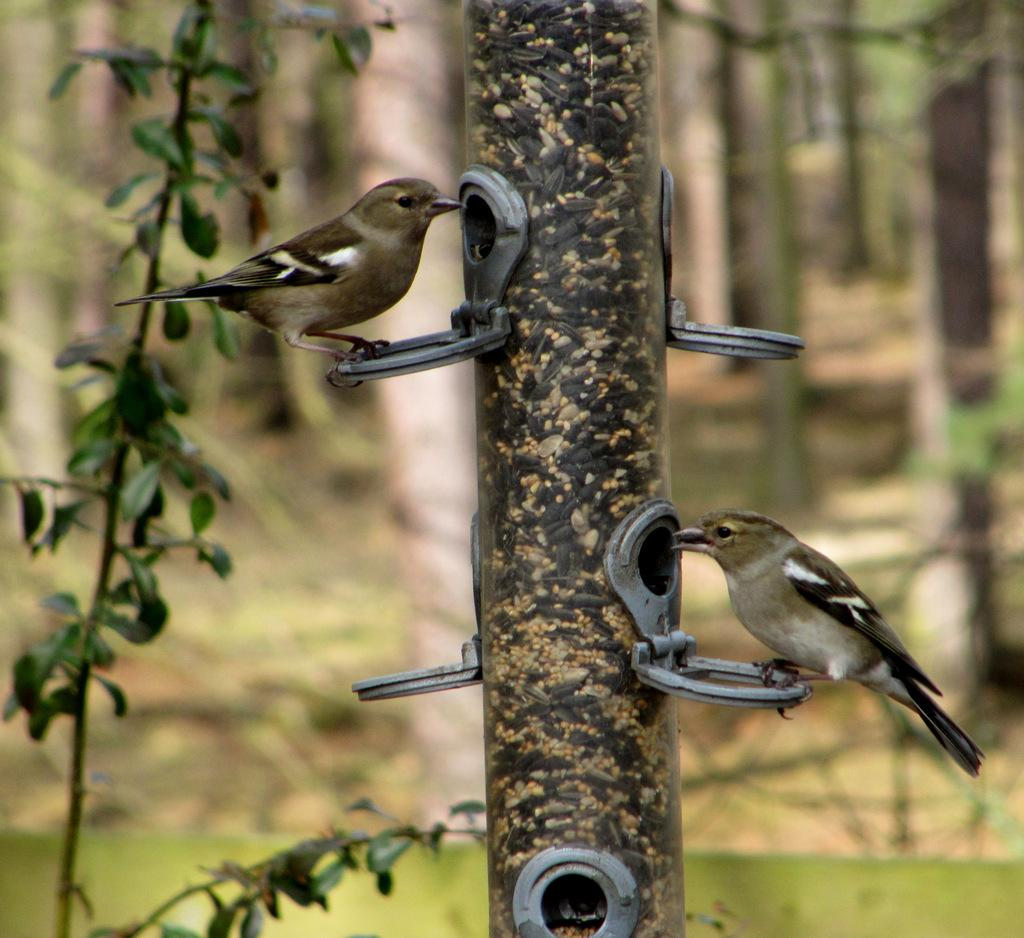What animals can be seen in the image? There are birds on a bird feeder in the image. What else is present in the image besides the birds? There are plants in the image. What type of bean is growing on the bird feeder in the image? There are no beans present in the image; it features birds on a bird feeder and plants. Can you describe the locket that the bird is wearing in the image? There are no lockets or jewelry visible on the birds in the image. 